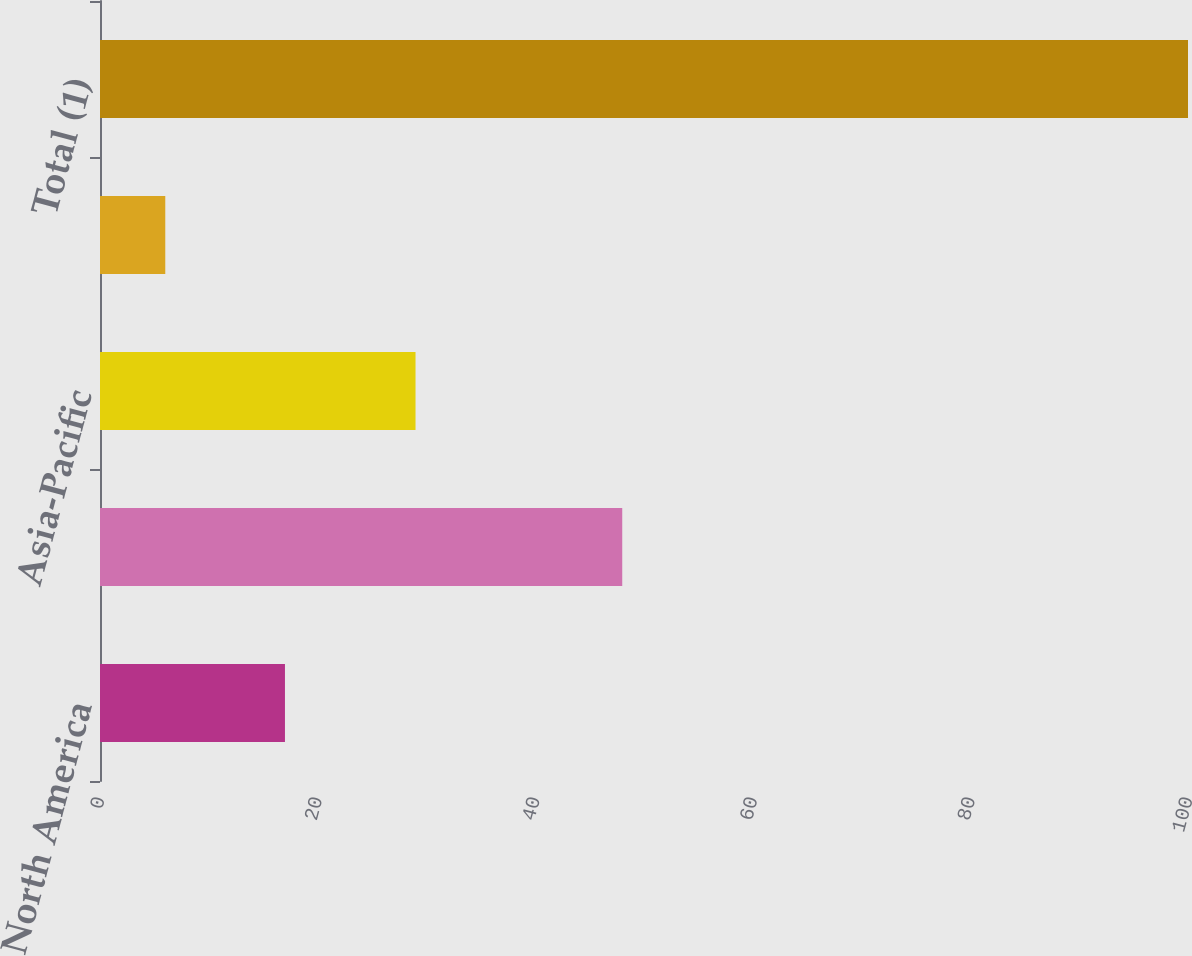Convert chart to OTSL. <chart><loc_0><loc_0><loc_500><loc_500><bar_chart><fcel>North America<fcel>Europe and Africa<fcel>Asia-Pacific<fcel>South America<fcel>Total (1)<nl><fcel>17<fcel>48<fcel>29<fcel>6<fcel>100<nl></chart> 